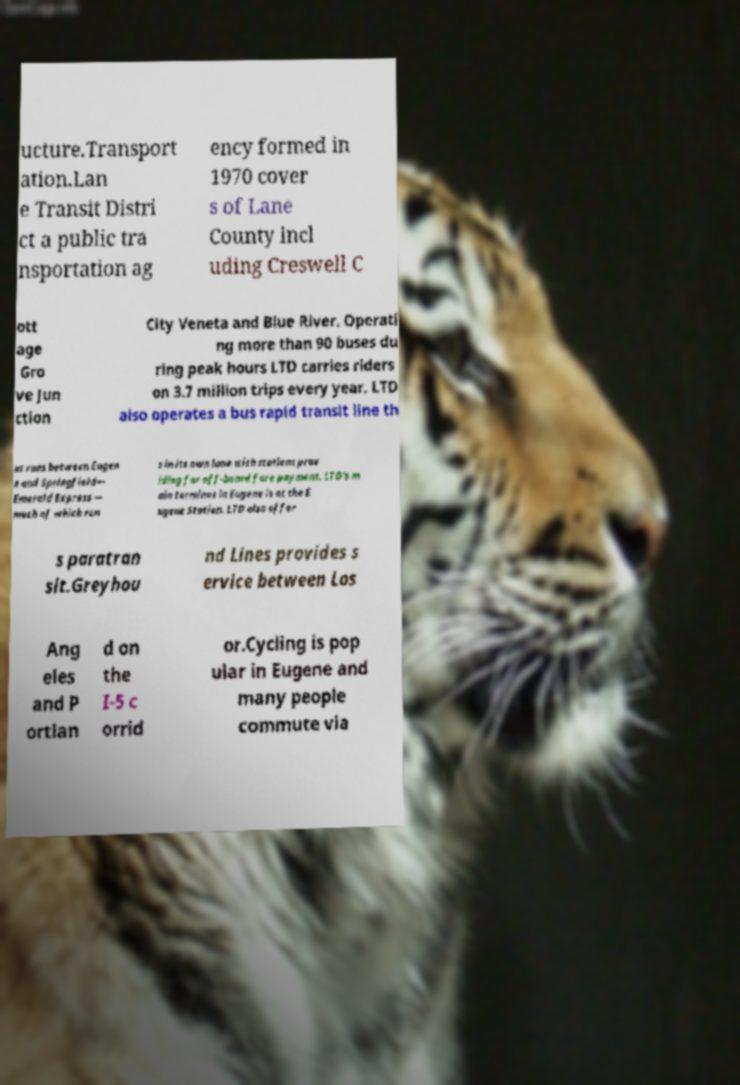For documentation purposes, I need the text within this image transcribed. Could you provide that? ucture.Transport ation.Lan e Transit Distri ct a public tra nsportation ag ency formed in 1970 cover s of Lane County incl uding Creswell C ott age Gro ve Jun ction City Veneta and Blue River. Operati ng more than 90 buses du ring peak hours LTD carries riders on 3.7 million trips every year. LTD also operates a bus rapid transit line th at runs between Eugen e and Springfield— Emerald Express — much of which run s in its own lane with stations prov iding for off-board fare payment. LTD's m ain terminus in Eugene is at the E ugene Station. LTD also offer s paratran sit.Greyhou nd Lines provides s ervice between Los Ang eles and P ortlan d on the I-5 c orrid or.Cycling is pop ular in Eugene and many people commute via 